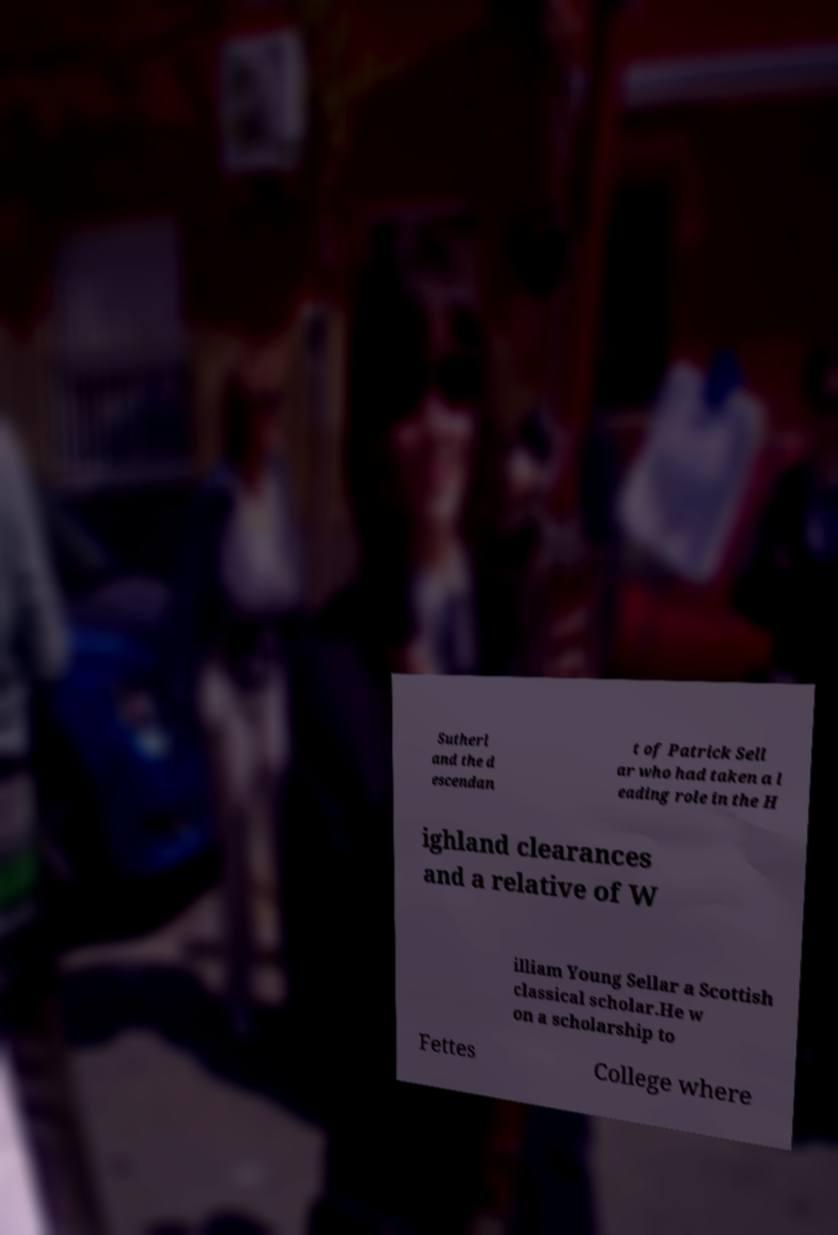What messages or text are displayed in this image? I need them in a readable, typed format. Sutherl and the d escendan t of Patrick Sell ar who had taken a l eading role in the H ighland clearances and a relative of W illiam Young Sellar a Scottish classical scholar.He w on a scholarship to Fettes College where 